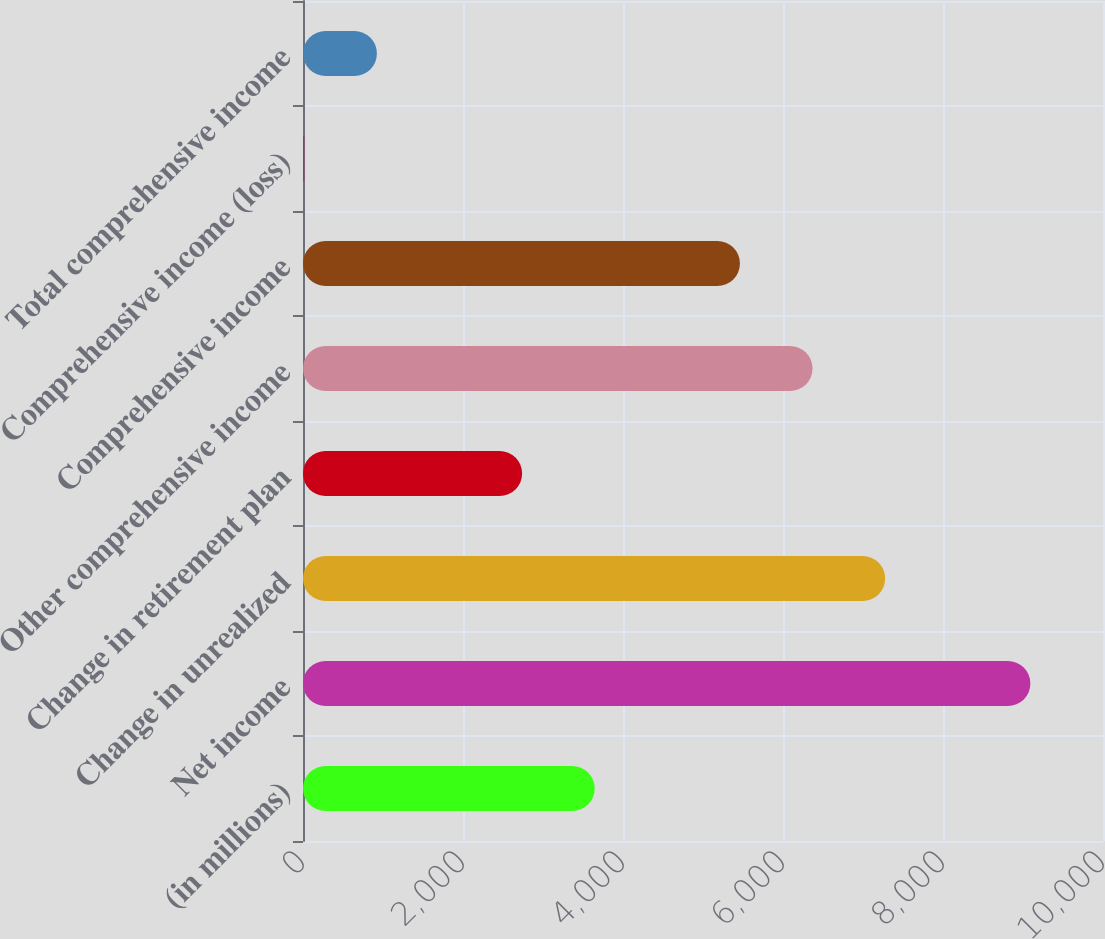Convert chart to OTSL. <chart><loc_0><loc_0><loc_500><loc_500><bar_chart><fcel>(in millions)<fcel>Net income<fcel>Change in unrealized<fcel>Change in retirement plan<fcel>Other comprehensive income<fcel>Comprehensive income<fcel>Comprehensive income (loss)<fcel>Total comprehensive income<nl><fcel>3646.4<fcel>9092<fcel>7276.8<fcel>2738.8<fcel>6369.2<fcel>5461.6<fcel>16<fcel>923.6<nl></chart> 